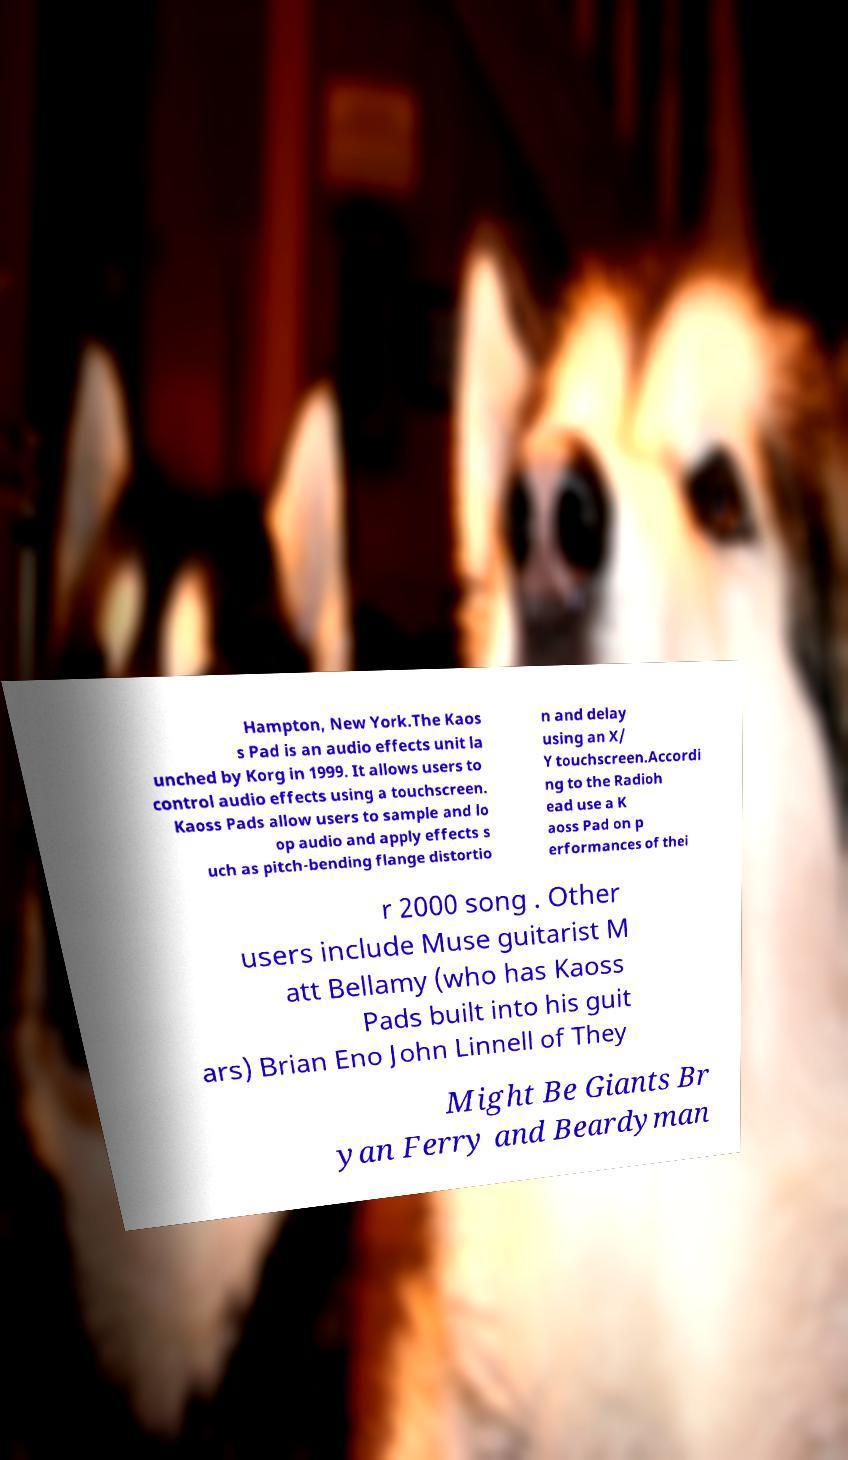For documentation purposes, I need the text within this image transcribed. Could you provide that? Hampton, New York.The Kaos s Pad is an audio effects unit la unched by Korg in 1999. It allows users to control audio effects using a touchscreen. Kaoss Pads allow users to sample and lo op audio and apply effects s uch as pitch-bending flange distortio n and delay using an X/ Y touchscreen.Accordi ng to the Radioh ead use a K aoss Pad on p erformances of thei r 2000 song . Other users include Muse guitarist M att Bellamy (who has Kaoss Pads built into his guit ars) Brian Eno John Linnell of They Might Be Giants Br yan Ferry and Beardyman 